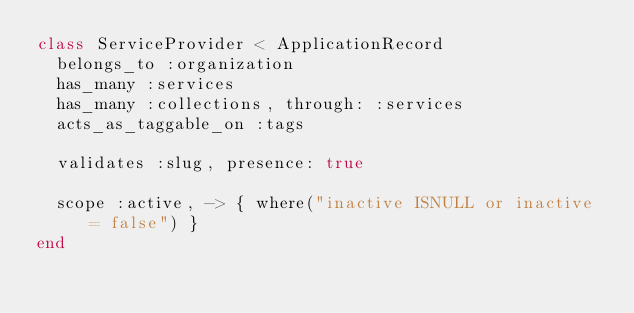Convert code to text. <code><loc_0><loc_0><loc_500><loc_500><_Ruby_>class ServiceProvider < ApplicationRecord
  belongs_to :organization
  has_many :services
  has_many :collections, through: :services
  acts_as_taggable_on :tags

  validates :slug, presence: true

  scope :active, -> { where("inactive ISNULL or inactive = false") }
end
</code> 